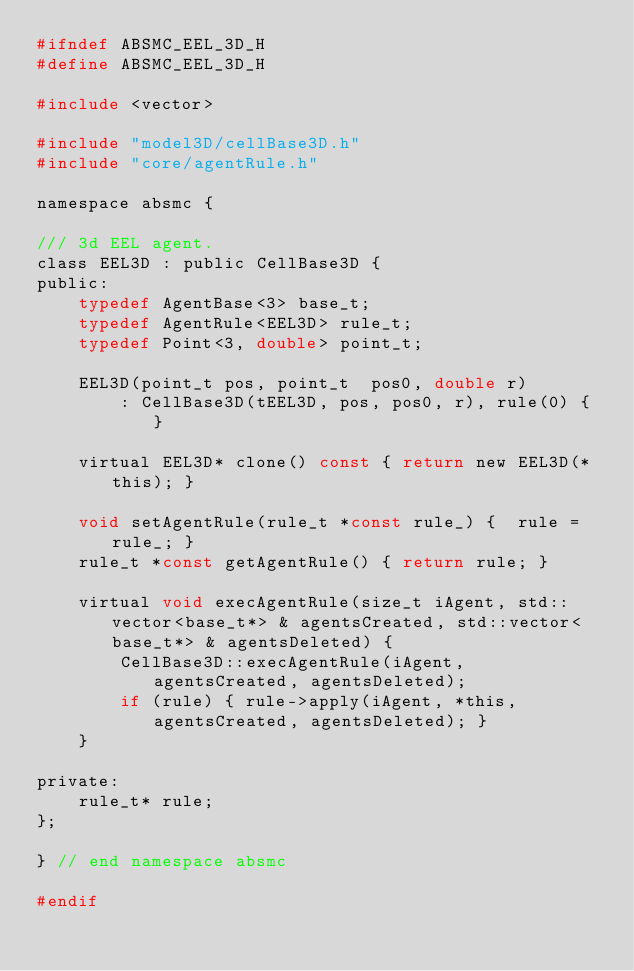Convert code to text. <code><loc_0><loc_0><loc_500><loc_500><_C_>#ifndef ABSMC_EEL_3D_H
#define ABSMC_EEL_3D_H

#include <vector>

#include "model3D/cellBase3D.h"
#include "core/agentRule.h"

namespace absmc {

/// 3d EEL agent.
class EEL3D : public CellBase3D {
public:
    typedef AgentBase<3> base_t;
    typedef AgentRule<EEL3D> rule_t;
    typedef Point<3, double> point_t;

    EEL3D(point_t pos, point_t  pos0, double r)
        : CellBase3D(tEEL3D, pos, pos0, r), rule(0) { }

    virtual EEL3D* clone() const { return new EEL3D(*this); }

    void setAgentRule(rule_t *const rule_) {  rule = rule_; }
    rule_t *const getAgentRule() { return rule; }

    virtual void execAgentRule(size_t iAgent, std::vector<base_t*> & agentsCreated, std::vector<base_t*> & agentsDeleted) {
        CellBase3D::execAgentRule(iAgent, agentsCreated, agentsDeleted);
        if (rule) { rule->apply(iAgent, *this, agentsCreated, agentsDeleted); }
    }

private:
    rule_t* rule;
};

} // end namespace absmc

#endif
</code> 